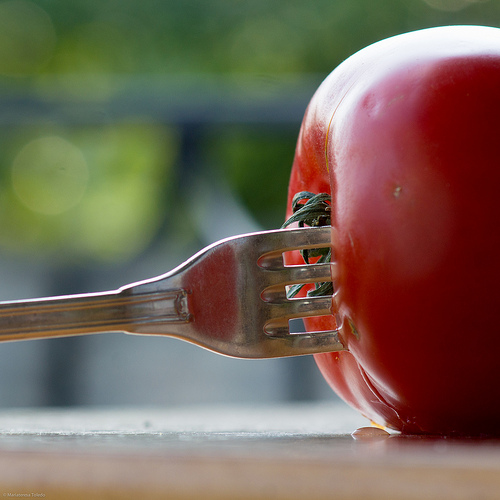<image>
Is there a tomato next to the fork? Yes. The tomato is positioned adjacent to the fork, located nearby in the same general area. Is there a fork in the tomato? Yes. The fork is contained within or inside the tomato, showing a containment relationship. Is there a fork behind the tomato? No. The fork is not behind the tomato. From this viewpoint, the fork appears to be positioned elsewhere in the scene. Is the tomato behind the fork? No. The tomato is not behind the fork. From this viewpoint, the tomato appears to be positioned elsewhere in the scene. Is there a fork to the left of the tomato? Yes. From this viewpoint, the fork is positioned to the left side relative to the tomato. 